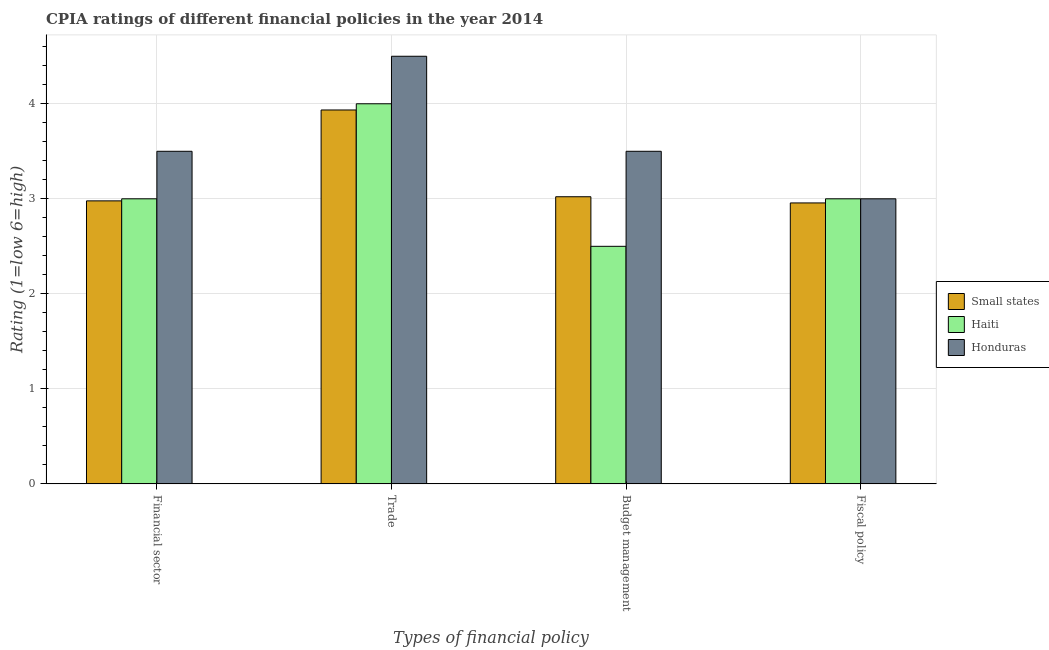How many different coloured bars are there?
Your response must be concise. 3. Are the number of bars on each tick of the X-axis equal?
Offer a very short reply. Yes. What is the label of the 3rd group of bars from the left?
Make the answer very short. Budget management. What is the cpia rating of trade in Small states?
Your answer should be compact. 3.93. In which country was the cpia rating of budget management maximum?
Your answer should be compact. Honduras. In which country was the cpia rating of trade minimum?
Keep it short and to the point. Small states. What is the total cpia rating of trade in the graph?
Make the answer very short. 12.43. What is the difference between the cpia rating of trade in Small states and that in Honduras?
Offer a very short reply. -0.57. What is the difference between the cpia rating of fiscal policy in Honduras and the cpia rating of financial sector in Small states?
Offer a terse response. 0.02. What is the average cpia rating of trade per country?
Give a very brief answer. 4.14. Is the cpia rating of fiscal policy in Honduras less than that in Haiti?
Your answer should be very brief. No. What is the difference between the highest and the lowest cpia rating of financial sector?
Ensure brevity in your answer.  0.52. In how many countries, is the cpia rating of financial sector greater than the average cpia rating of financial sector taken over all countries?
Offer a terse response. 1. Is it the case that in every country, the sum of the cpia rating of trade and cpia rating of fiscal policy is greater than the sum of cpia rating of financial sector and cpia rating of budget management?
Keep it short and to the point. No. What does the 1st bar from the left in Fiscal policy represents?
Keep it short and to the point. Small states. What does the 1st bar from the right in Budget management represents?
Your answer should be very brief. Honduras. Is it the case that in every country, the sum of the cpia rating of financial sector and cpia rating of trade is greater than the cpia rating of budget management?
Offer a very short reply. Yes. Does the graph contain any zero values?
Your answer should be compact. No. How are the legend labels stacked?
Keep it short and to the point. Vertical. What is the title of the graph?
Offer a very short reply. CPIA ratings of different financial policies in the year 2014. What is the label or title of the X-axis?
Make the answer very short. Types of financial policy. What is the Rating (1=low 6=high) of Small states in Financial sector?
Ensure brevity in your answer.  2.98. What is the Rating (1=low 6=high) in Haiti in Financial sector?
Your answer should be very brief. 3. What is the Rating (1=low 6=high) of Honduras in Financial sector?
Your answer should be compact. 3.5. What is the Rating (1=low 6=high) of Small states in Trade?
Your answer should be compact. 3.93. What is the Rating (1=low 6=high) in Honduras in Trade?
Provide a succinct answer. 4.5. What is the Rating (1=low 6=high) of Small states in Budget management?
Provide a short and direct response. 3.02. What is the Rating (1=low 6=high) of Haiti in Budget management?
Your answer should be very brief. 2.5. What is the Rating (1=low 6=high) of Small states in Fiscal policy?
Provide a short and direct response. 2.96. What is the Rating (1=low 6=high) of Honduras in Fiscal policy?
Your response must be concise. 3. Across all Types of financial policy, what is the maximum Rating (1=low 6=high) in Small states?
Make the answer very short. 3.93. Across all Types of financial policy, what is the maximum Rating (1=low 6=high) in Haiti?
Keep it short and to the point. 4. Across all Types of financial policy, what is the maximum Rating (1=low 6=high) of Honduras?
Your response must be concise. 4.5. Across all Types of financial policy, what is the minimum Rating (1=low 6=high) of Small states?
Offer a terse response. 2.96. Across all Types of financial policy, what is the minimum Rating (1=low 6=high) in Honduras?
Ensure brevity in your answer.  3. What is the total Rating (1=low 6=high) in Small states in the graph?
Provide a succinct answer. 12.89. What is the difference between the Rating (1=low 6=high) in Small states in Financial sector and that in Trade?
Your answer should be compact. -0.96. What is the difference between the Rating (1=low 6=high) of Haiti in Financial sector and that in Trade?
Provide a succinct answer. -1. What is the difference between the Rating (1=low 6=high) in Small states in Financial sector and that in Budget management?
Keep it short and to the point. -0.04. What is the difference between the Rating (1=low 6=high) in Small states in Financial sector and that in Fiscal policy?
Your answer should be compact. 0.02. What is the difference between the Rating (1=low 6=high) in Haiti in Financial sector and that in Fiscal policy?
Provide a short and direct response. 0. What is the difference between the Rating (1=low 6=high) of Haiti in Trade and that in Budget management?
Offer a very short reply. 1.5. What is the difference between the Rating (1=low 6=high) in Small states in Trade and that in Fiscal policy?
Your answer should be very brief. 0.98. What is the difference between the Rating (1=low 6=high) of Small states in Budget management and that in Fiscal policy?
Provide a succinct answer. 0.07. What is the difference between the Rating (1=low 6=high) of Haiti in Budget management and that in Fiscal policy?
Keep it short and to the point. -0.5. What is the difference between the Rating (1=low 6=high) of Honduras in Budget management and that in Fiscal policy?
Provide a short and direct response. 0.5. What is the difference between the Rating (1=low 6=high) in Small states in Financial sector and the Rating (1=low 6=high) in Haiti in Trade?
Offer a very short reply. -1.02. What is the difference between the Rating (1=low 6=high) of Small states in Financial sector and the Rating (1=low 6=high) of Honduras in Trade?
Provide a succinct answer. -1.52. What is the difference between the Rating (1=low 6=high) in Small states in Financial sector and the Rating (1=low 6=high) in Haiti in Budget management?
Your answer should be compact. 0.48. What is the difference between the Rating (1=low 6=high) of Small states in Financial sector and the Rating (1=low 6=high) of Honduras in Budget management?
Give a very brief answer. -0.52. What is the difference between the Rating (1=low 6=high) of Haiti in Financial sector and the Rating (1=low 6=high) of Honduras in Budget management?
Keep it short and to the point. -0.5. What is the difference between the Rating (1=low 6=high) of Small states in Financial sector and the Rating (1=low 6=high) of Haiti in Fiscal policy?
Keep it short and to the point. -0.02. What is the difference between the Rating (1=low 6=high) of Small states in Financial sector and the Rating (1=low 6=high) of Honduras in Fiscal policy?
Provide a succinct answer. -0.02. What is the difference between the Rating (1=low 6=high) of Small states in Trade and the Rating (1=low 6=high) of Haiti in Budget management?
Provide a succinct answer. 1.43. What is the difference between the Rating (1=low 6=high) in Small states in Trade and the Rating (1=low 6=high) in Honduras in Budget management?
Keep it short and to the point. 0.43. What is the difference between the Rating (1=low 6=high) of Haiti in Trade and the Rating (1=low 6=high) of Honduras in Budget management?
Provide a short and direct response. 0.5. What is the difference between the Rating (1=low 6=high) of Small states in Trade and the Rating (1=low 6=high) of Haiti in Fiscal policy?
Your response must be concise. 0.93. What is the difference between the Rating (1=low 6=high) in Small states in Trade and the Rating (1=low 6=high) in Honduras in Fiscal policy?
Keep it short and to the point. 0.93. What is the difference between the Rating (1=low 6=high) of Haiti in Trade and the Rating (1=low 6=high) of Honduras in Fiscal policy?
Your answer should be very brief. 1. What is the difference between the Rating (1=low 6=high) of Small states in Budget management and the Rating (1=low 6=high) of Haiti in Fiscal policy?
Make the answer very short. 0.02. What is the difference between the Rating (1=low 6=high) of Small states in Budget management and the Rating (1=low 6=high) of Honduras in Fiscal policy?
Make the answer very short. 0.02. What is the average Rating (1=low 6=high) of Small states per Types of financial policy?
Make the answer very short. 3.22. What is the average Rating (1=low 6=high) of Haiti per Types of financial policy?
Your answer should be compact. 3.12. What is the average Rating (1=low 6=high) in Honduras per Types of financial policy?
Your answer should be very brief. 3.62. What is the difference between the Rating (1=low 6=high) in Small states and Rating (1=low 6=high) in Haiti in Financial sector?
Ensure brevity in your answer.  -0.02. What is the difference between the Rating (1=low 6=high) in Small states and Rating (1=low 6=high) in Honduras in Financial sector?
Offer a terse response. -0.52. What is the difference between the Rating (1=low 6=high) of Small states and Rating (1=low 6=high) of Haiti in Trade?
Ensure brevity in your answer.  -0.07. What is the difference between the Rating (1=low 6=high) in Small states and Rating (1=low 6=high) in Honduras in Trade?
Provide a short and direct response. -0.57. What is the difference between the Rating (1=low 6=high) of Small states and Rating (1=low 6=high) of Haiti in Budget management?
Your answer should be very brief. 0.52. What is the difference between the Rating (1=low 6=high) in Small states and Rating (1=low 6=high) in Honduras in Budget management?
Your answer should be very brief. -0.48. What is the difference between the Rating (1=low 6=high) of Small states and Rating (1=low 6=high) of Haiti in Fiscal policy?
Keep it short and to the point. -0.04. What is the difference between the Rating (1=low 6=high) of Small states and Rating (1=low 6=high) of Honduras in Fiscal policy?
Make the answer very short. -0.04. What is the difference between the Rating (1=low 6=high) in Haiti and Rating (1=low 6=high) in Honduras in Fiscal policy?
Provide a succinct answer. 0. What is the ratio of the Rating (1=low 6=high) in Small states in Financial sector to that in Trade?
Provide a short and direct response. 0.76. What is the ratio of the Rating (1=low 6=high) in Honduras in Financial sector to that in Trade?
Offer a very short reply. 0.78. What is the ratio of the Rating (1=low 6=high) in Small states in Financial sector to that in Budget management?
Offer a very short reply. 0.99. What is the ratio of the Rating (1=low 6=high) in Honduras in Financial sector to that in Budget management?
Keep it short and to the point. 1. What is the ratio of the Rating (1=low 6=high) in Small states in Financial sector to that in Fiscal policy?
Your answer should be compact. 1.01. What is the ratio of the Rating (1=low 6=high) in Small states in Trade to that in Budget management?
Keep it short and to the point. 1.3. What is the ratio of the Rating (1=low 6=high) in Honduras in Trade to that in Budget management?
Offer a terse response. 1.29. What is the ratio of the Rating (1=low 6=high) in Small states in Trade to that in Fiscal policy?
Your answer should be compact. 1.33. What is the ratio of the Rating (1=low 6=high) in Honduras in Trade to that in Fiscal policy?
Give a very brief answer. 1.5. What is the ratio of the Rating (1=low 6=high) in Small states in Budget management to that in Fiscal policy?
Your response must be concise. 1.02. What is the ratio of the Rating (1=low 6=high) of Haiti in Budget management to that in Fiscal policy?
Offer a terse response. 0.83. What is the difference between the highest and the lowest Rating (1=low 6=high) of Small states?
Provide a succinct answer. 0.98. What is the difference between the highest and the lowest Rating (1=low 6=high) of Haiti?
Your answer should be compact. 1.5. What is the difference between the highest and the lowest Rating (1=low 6=high) in Honduras?
Give a very brief answer. 1.5. 